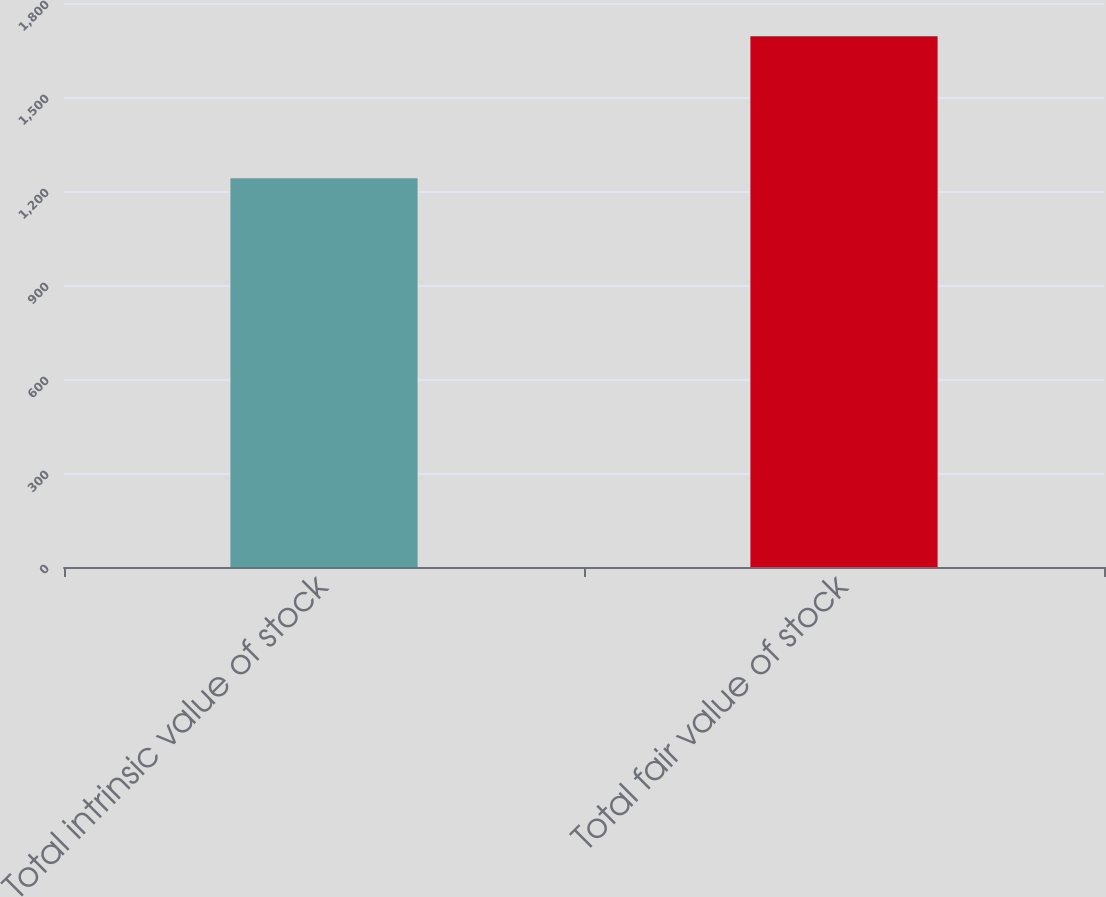<chart> <loc_0><loc_0><loc_500><loc_500><bar_chart><fcel>Total intrinsic value of stock<fcel>Total fair value of stock<nl><fcel>1241<fcel>1694<nl></chart> 